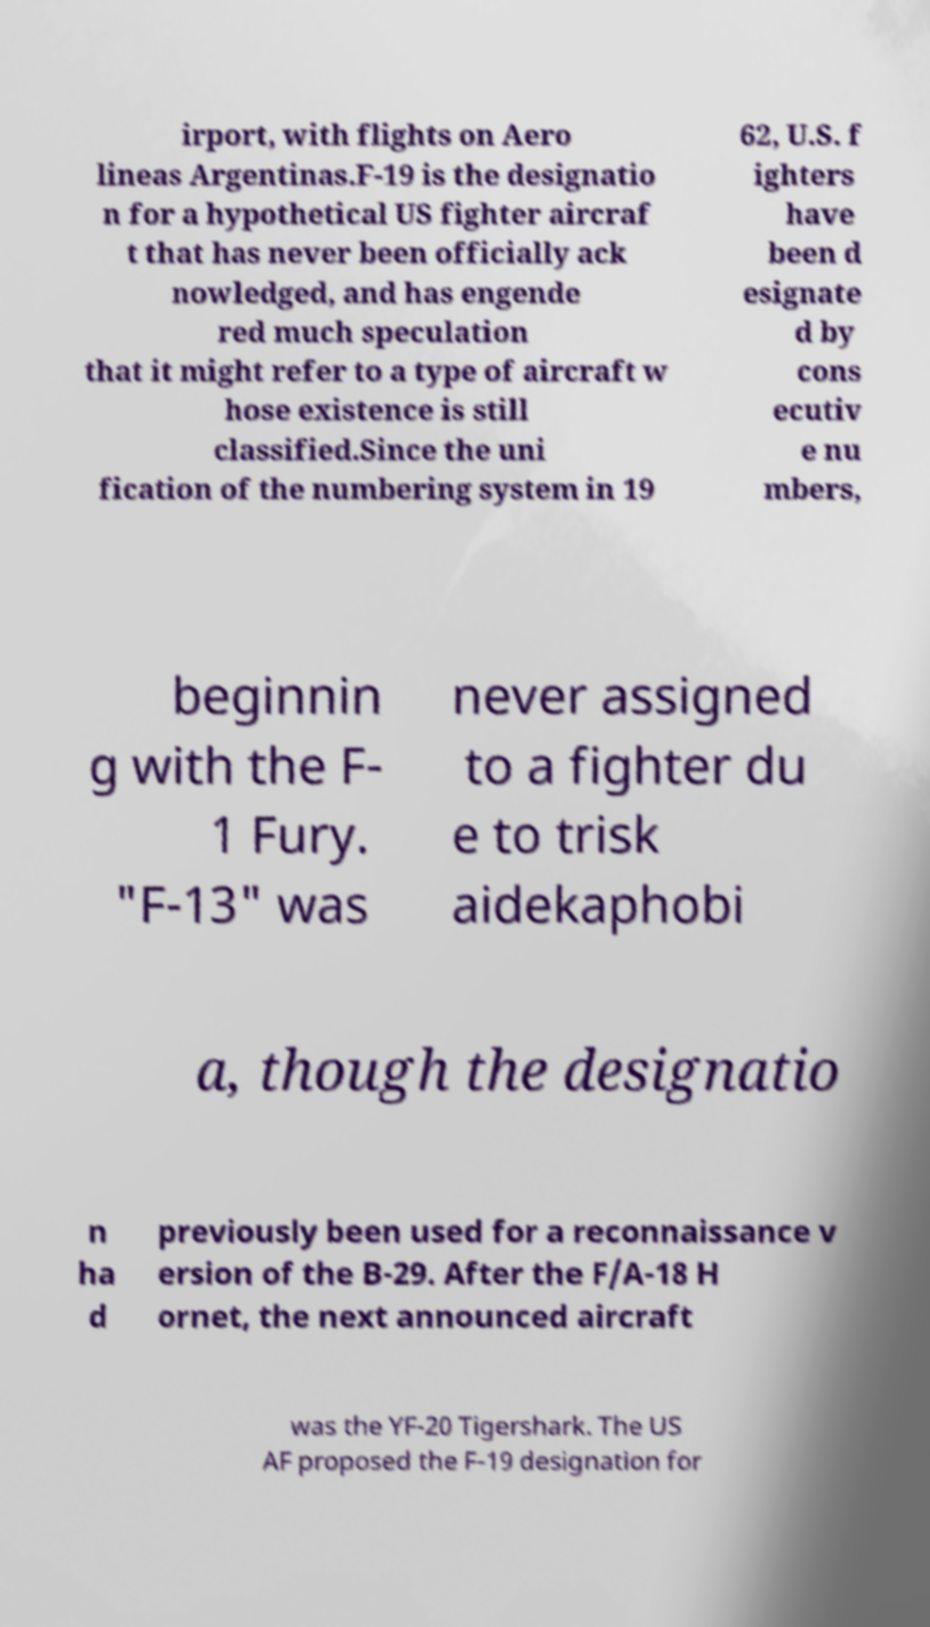Please identify and transcribe the text found in this image. irport, with flights on Aero lineas Argentinas.F-19 is the designatio n for a hypothetical US fighter aircraf t that has never been officially ack nowledged, and has engende red much speculation that it might refer to a type of aircraft w hose existence is still classified.Since the uni fication of the numbering system in 19 62, U.S. f ighters have been d esignate d by cons ecutiv e nu mbers, beginnin g with the F- 1 Fury. "F-13" was never assigned to a fighter du e to trisk aidekaphobi a, though the designatio n ha d previously been used for a reconnaissance v ersion of the B-29. After the F/A-18 H ornet, the next announced aircraft was the YF-20 Tigershark. The US AF proposed the F-19 designation for 